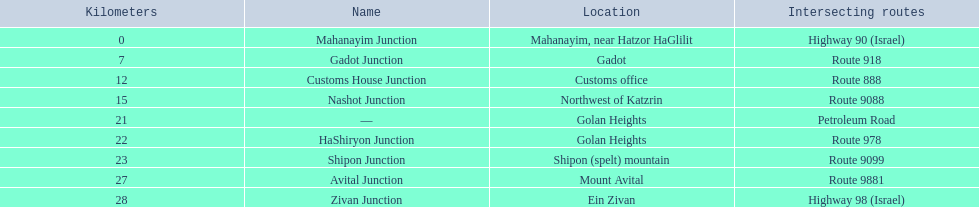What are the different places on highway 91 (israel)? Mahanayim, near Hatzor HaGlilit, Gadot, Customs office, Northwest of Katzrin, Golan Heights, Golan Heights, Shipon (spelt) mountain, Mount Avital, Ein Zivan. What are the distance figures in kilometers for ein zivan, gadot junction, and shipon junction? 7, 23, 28. Which one has the smallest distance? 7. What is the name? Gadot Junction. 